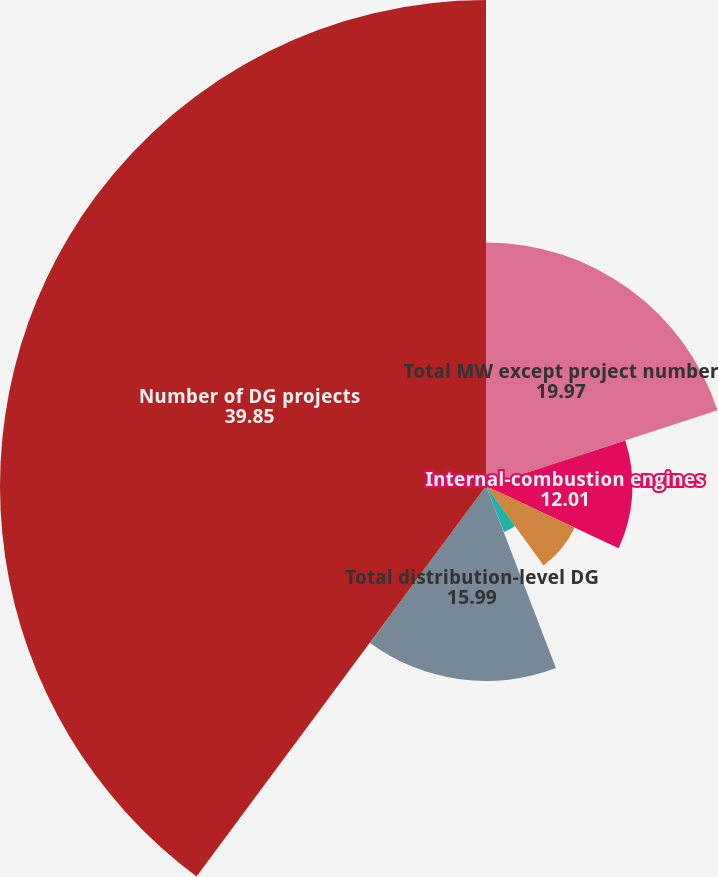<chart> <loc_0><loc_0><loc_500><loc_500><pie_chart><fcel>Total MW except project number<fcel>Internal-combustion engines<fcel>Photovoltaic solar<fcel>Gas turbines<fcel>Micro turbines<fcel>Total distribution-level DG<fcel>Number of DG projects<nl><fcel>19.97%<fcel>12.01%<fcel>8.04%<fcel>4.06%<fcel>0.09%<fcel>15.99%<fcel>39.85%<nl></chart> 